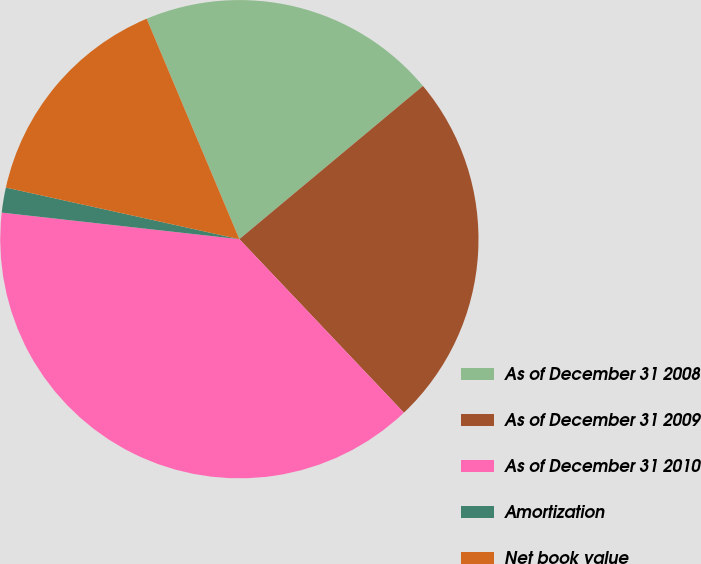<chart> <loc_0><loc_0><loc_500><loc_500><pie_chart><fcel>As of December 31 2008<fcel>As of December 31 2009<fcel>As of December 31 2010<fcel>Amortization<fcel>Net book value<nl><fcel>20.27%<fcel>23.99%<fcel>38.85%<fcel>1.69%<fcel>15.2%<nl></chart> 